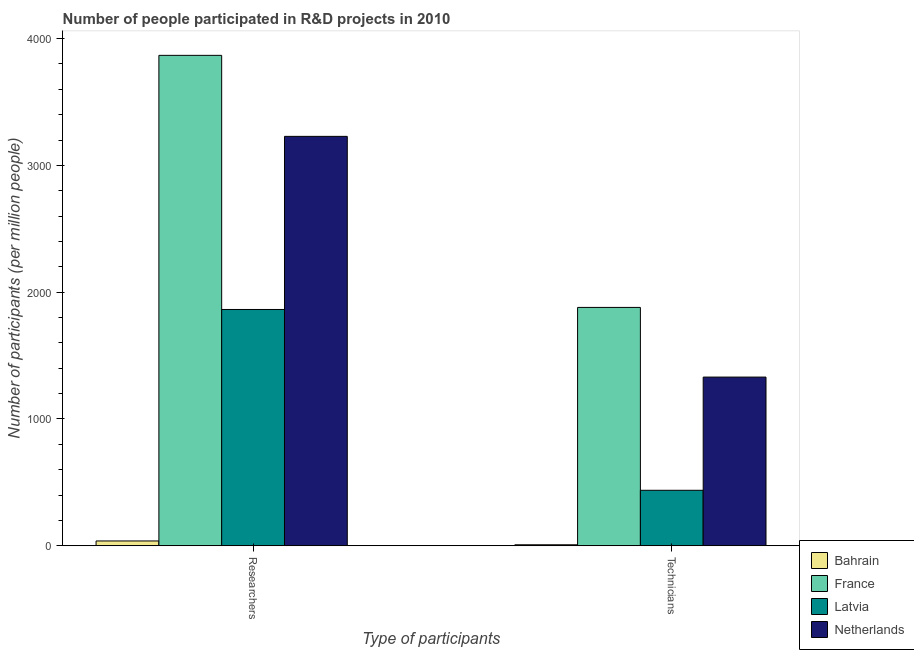How many different coloured bars are there?
Your answer should be very brief. 4. How many groups of bars are there?
Offer a very short reply. 2. How many bars are there on the 1st tick from the right?
Your answer should be very brief. 4. What is the label of the 2nd group of bars from the left?
Your response must be concise. Technicians. What is the number of technicians in Bahrain?
Offer a very short reply. 7.93. Across all countries, what is the maximum number of technicians?
Your answer should be very brief. 1879.95. Across all countries, what is the minimum number of researchers?
Your response must be concise. 38.06. In which country was the number of technicians maximum?
Your answer should be compact. France. In which country was the number of technicians minimum?
Your response must be concise. Bahrain. What is the total number of researchers in the graph?
Give a very brief answer. 8998.68. What is the difference between the number of researchers in France and that in Bahrain?
Give a very brief answer. 3829.94. What is the difference between the number of technicians in Netherlands and the number of researchers in Latvia?
Your answer should be very brief. -533.17. What is the average number of technicians per country?
Your response must be concise. 914.01. What is the difference between the number of researchers and number of technicians in Latvia?
Offer a very short reply. 1425.96. In how many countries, is the number of researchers greater than 2600 ?
Make the answer very short. 2. What is the ratio of the number of researchers in France to that in Latvia?
Keep it short and to the point. 2.08. What does the 3rd bar from the left in Technicians represents?
Offer a terse response. Latvia. What does the 2nd bar from the right in Technicians represents?
Provide a succinct answer. Latvia. How many bars are there?
Provide a succinct answer. 8. How many countries are there in the graph?
Provide a succinct answer. 4. Does the graph contain grids?
Make the answer very short. No. How many legend labels are there?
Provide a succinct answer. 4. What is the title of the graph?
Provide a succinct answer. Number of people participated in R&D projects in 2010. What is the label or title of the X-axis?
Provide a short and direct response. Type of participants. What is the label or title of the Y-axis?
Offer a terse response. Number of participants (per million people). What is the Number of participants (per million people) of Bahrain in Researchers?
Give a very brief answer. 38.06. What is the Number of participants (per million people) in France in Researchers?
Offer a terse response. 3867.99. What is the Number of participants (per million people) in Latvia in Researchers?
Keep it short and to the point. 1863.65. What is the Number of participants (per million people) in Netherlands in Researchers?
Offer a very short reply. 3228.98. What is the Number of participants (per million people) of Bahrain in Technicians?
Your answer should be compact. 7.93. What is the Number of participants (per million people) in France in Technicians?
Give a very brief answer. 1879.95. What is the Number of participants (per million people) of Latvia in Technicians?
Give a very brief answer. 437.69. What is the Number of participants (per million people) in Netherlands in Technicians?
Your response must be concise. 1330.48. Across all Type of participants, what is the maximum Number of participants (per million people) of Bahrain?
Make the answer very short. 38.06. Across all Type of participants, what is the maximum Number of participants (per million people) of France?
Make the answer very short. 3867.99. Across all Type of participants, what is the maximum Number of participants (per million people) in Latvia?
Give a very brief answer. 1863.65. Across all Type of participants, what is the maximum Number of participants (per million people) in Netherlands?
Offer a terse response. 3228.98. Across all Type of participants, what is the minimum Number of participants (per million people) in Bahrain?
Provide a short and direct response. 7.93. Across all Type of participants, what is the minimum Number of participants (per million people) of France?
Your response must be concise. 1879.95. Across all Type of participants, what is the minimum Number of participants (per million people) of Latvia?
Give a very brief answer. 437.69. Across all Type of participants, what is the minimum Number of participants (per million people) in Netherlands?
Offer a very short reply. 1330.48. What is the total Number of participants (per million people) of Bahrain in the graph?
Give a very brief answer. 45.98. What is the total Number of participants (per million people) in France in the graph?
Provide a succinct answer. 5747.94. What is the total Number of participants (per million people) of Latvia in the graph?
Give a very brief answer. 2301.34. What is the total Number of participants (per million people) in Netherlands in the graph?
Give a very brief answer. 4559.46. What is the difference between the Number of participants (per million people) in Bahrain in Researchers and that in Technicians?
Give a very brief answer. 30.13. What is the difference between the Number of participants (per million people) of France in Researchers and that in Technicians?
Offer a terse response. 1988.05. What is the difference between the Number of participants (per million people) in Latvia in Researchers and that in Technicians?
Provide a short and direct response. 1425.96. What is the difference between the Number of participants (per million people) of Netherlands in Researchers and that in Technicians?
Provide a succinct answer. 1898.5. What is the difference between the Number of participants (per million people) in Bahrain in Researchers and the Number of participants (per million people) in France in Technicians?
Give a very brief answer. -1841.89. What is the difference between the Number of participants (per million people) in Bahrain in Researchers and the Number of participants (per million people) in Latvia in Technicians?
Keep it short and to the point. -399.63. What is the difference between the Number of participants (per million people) in Bahrain in Researchers and the Number of participants (per million people) in Netherlands in Technicians?
Your answer should be compact. -1292.43. What is the difference between the Number of participants (per million people) of France in Researchers and the Number of participants (per million people) of Latvia in Technicians?
Provide a succinct answer. 3430.3. What is the difference between the Number of participants (per million people) in France in Researchers and the Number of participants (per million people) in Netherlands in Technicians?
Make the answer very short. 2537.51. What is the difference between the Number of participants (per million people) in Latvia in Researchers and the Number of participants (per million people) in Netherlands in Technicians?
Your response must be concise. 533.17. What is the average Number of participants (per million people) of Bahrain per Type of participants?
Make the answer very short. 22.99. What is the average Number of participants (per million people) of France per Type of participants?
Give a very brief answer. 2873.97. What is the average Number of participants (per million people) in Latvia per Type of participants?
Your answer should be very brief. 1150.67. What is the average Number of participants (per million people) in Netherlands per Type of participants?
Your response must be concise. 2279.73. What is the difference between the Number of participants (per million people) of Bahrain and Number of participants (per million people) of France in Researchers?
Give a very brief answer. -3829.94. What is the difference between the Number of participants (per million people) of Bahrain and Number of participants (per million people) of Latvia in Researchers?
Make the answer very short. -1825.6. What is the difference between the Number of participants (per million people) in Bahrain and Number of participants (per million people) in Netherlands in Researchers?
Give a very brief answer. -3190.92. What is the difference between the Number of participants (per million people) in France and Number of participants (per million people) in Latvia in Researchers?
Offer a very short reply. 2004.34. What is the difference between the Number of participants (per million people) of France and Number of participants (per million people) of Netherlands in Researchers?
Your answer should be very brief. 639.01. What is the difference between the Number of participants (per million people) of Latvia and Number of participants (per million people) of Netherlands in Researchers?
Your answer should be compact. -1365.33. What is the difference between the Number of participants (per million people) in Bahrain and Number of participants (per million people) in France in Technicians?
Make the answer very short. -1872.02. What is the difference between the Number of participants (per million people) in Bahrain and Number of participants (per million people) in Latvia in Technicians?
Ensure brevity in your answer.  -429.76. What is the difference between the Number of participants (per million people) in Bahrain and Number of participants (per million people) in Netherlands in Technicians?
Give a very brief answer. -1322.55. What is the difference between the Number of participants (per million people) in France and Number of participants (per million people) in Latvia in Technicians?
Provide a succinct answer. 1442.26. What is the difference between the Number of participants (per million people) in France and Number of participants (per million people) in Netherlands in Technicians?
Provide a succinct answer. 549.46. What is the difference between the Number of participants (per million people) in Latvia and Number of participants (per million people) in Netherlands in Technicians?
Keep it short and to the point. -892.79. What is the ratio of the Number of participants (per million people) in Bahrain in Researchers to that in Technicians?
Your answer should be compact. 4.8. What is the ratio of the Number of participants (per million people) in France in Researchers to that in Technicians?
Keep it short and to the point. 2.06. What is the ratio of the Number of participants (per million people) in Latvia in Researchers to that in Technicians?
Offer a terse response. 4.26. What is the ratio of the Number of participants (per million people) of Netherlands in Researchers to that in Technicians?
Your answer should be compact. 2.43. What is the difference between the highest and the second highest Number of participants (per million people) of Bahrain?
Offer a terse response. 30.13. What is the difference between the highest and the second highest Number of participants (per million people) of France?
Provide a short and direct response. 1988.05. What is the difference between the highest and the second highest Number of participants (per million people) of Latvia?
Give a very brief answer. 1425.96. What is the difference between the highest and the second highest Number of participants (per million people) in Netherlands?
Keep it short and to the point. 1898.5. What is the difference between the highest and the lowest Number of participants (per million people) in Bahrain?
Provide a succinct answer. 30.13. What is the difference between the highest and the lowest Number of participants (per million people) of France?
Your response must be concise. 1988.05. What is the difference between the highest and the lowest Number of participants (per million people) in Latvia?
Your answer should be very brief. 1425.96. What is the difference between the highest and the lowest Number of participants (per million people) of Netherlands?
Your response must be concise. 1898.5. 